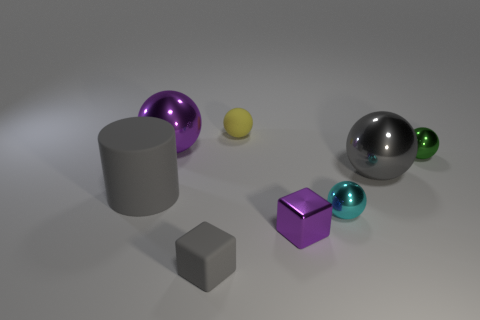Do the large cylinder and the tiny cube on the left side of the tiny yellow matte object have the same color?
Provide a short and direct response. Yes. What size is the ball that is both in front of the tiny yellow sphere and on the left side of the small purple metal object?
Keep it short and to the point. Large. What number of other objects are there of the same color as the matte block?
Your response must be concise. 2. There is a purple thing to the left of the rubber object that is behind the big metal ball to the left of the small matte sphere; what is its size?
Keep it short and to the point. Large. There is a cyan thing; are there any big cylinders in front of it?
Your answer should be compact. No. There is a cyan metal sphere; is its size the same as the purple metallic thing behind the cyan object?
Your response must be concise. No. How many other things are the same material as the large cylinder?
Offer a terse response. 2. There is a gray object that is on the right side of the big matte cylinder and behind the gray rubber cube; what shape is it?
Your answer should be compact. Sphere. Do the metallic object left of the small matte ball and the gray matte thing behind the tiny purple thing have the same size?
Give a very brief answer. Yes. What is the shape of the gray object that is made of the same material as the big gray cylinder?
Keep it short and to the point. Cube. 